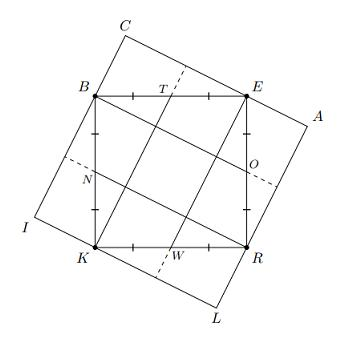Can you describe the properties of the diagonals in the square BERK relative to the square CALI demonstrated in the image? In the image, the diagonals of both squares, BERK and CALI, appear to be perpendicular to each other. Each diagonal of BERK intersects corresponding midpoints of its sides, creating four right triangles within each square. The diagonals not only bisect each square into equal halves but are equal in length, reinforcing the property that these squares maintain the same dimensions despite the rotation. 